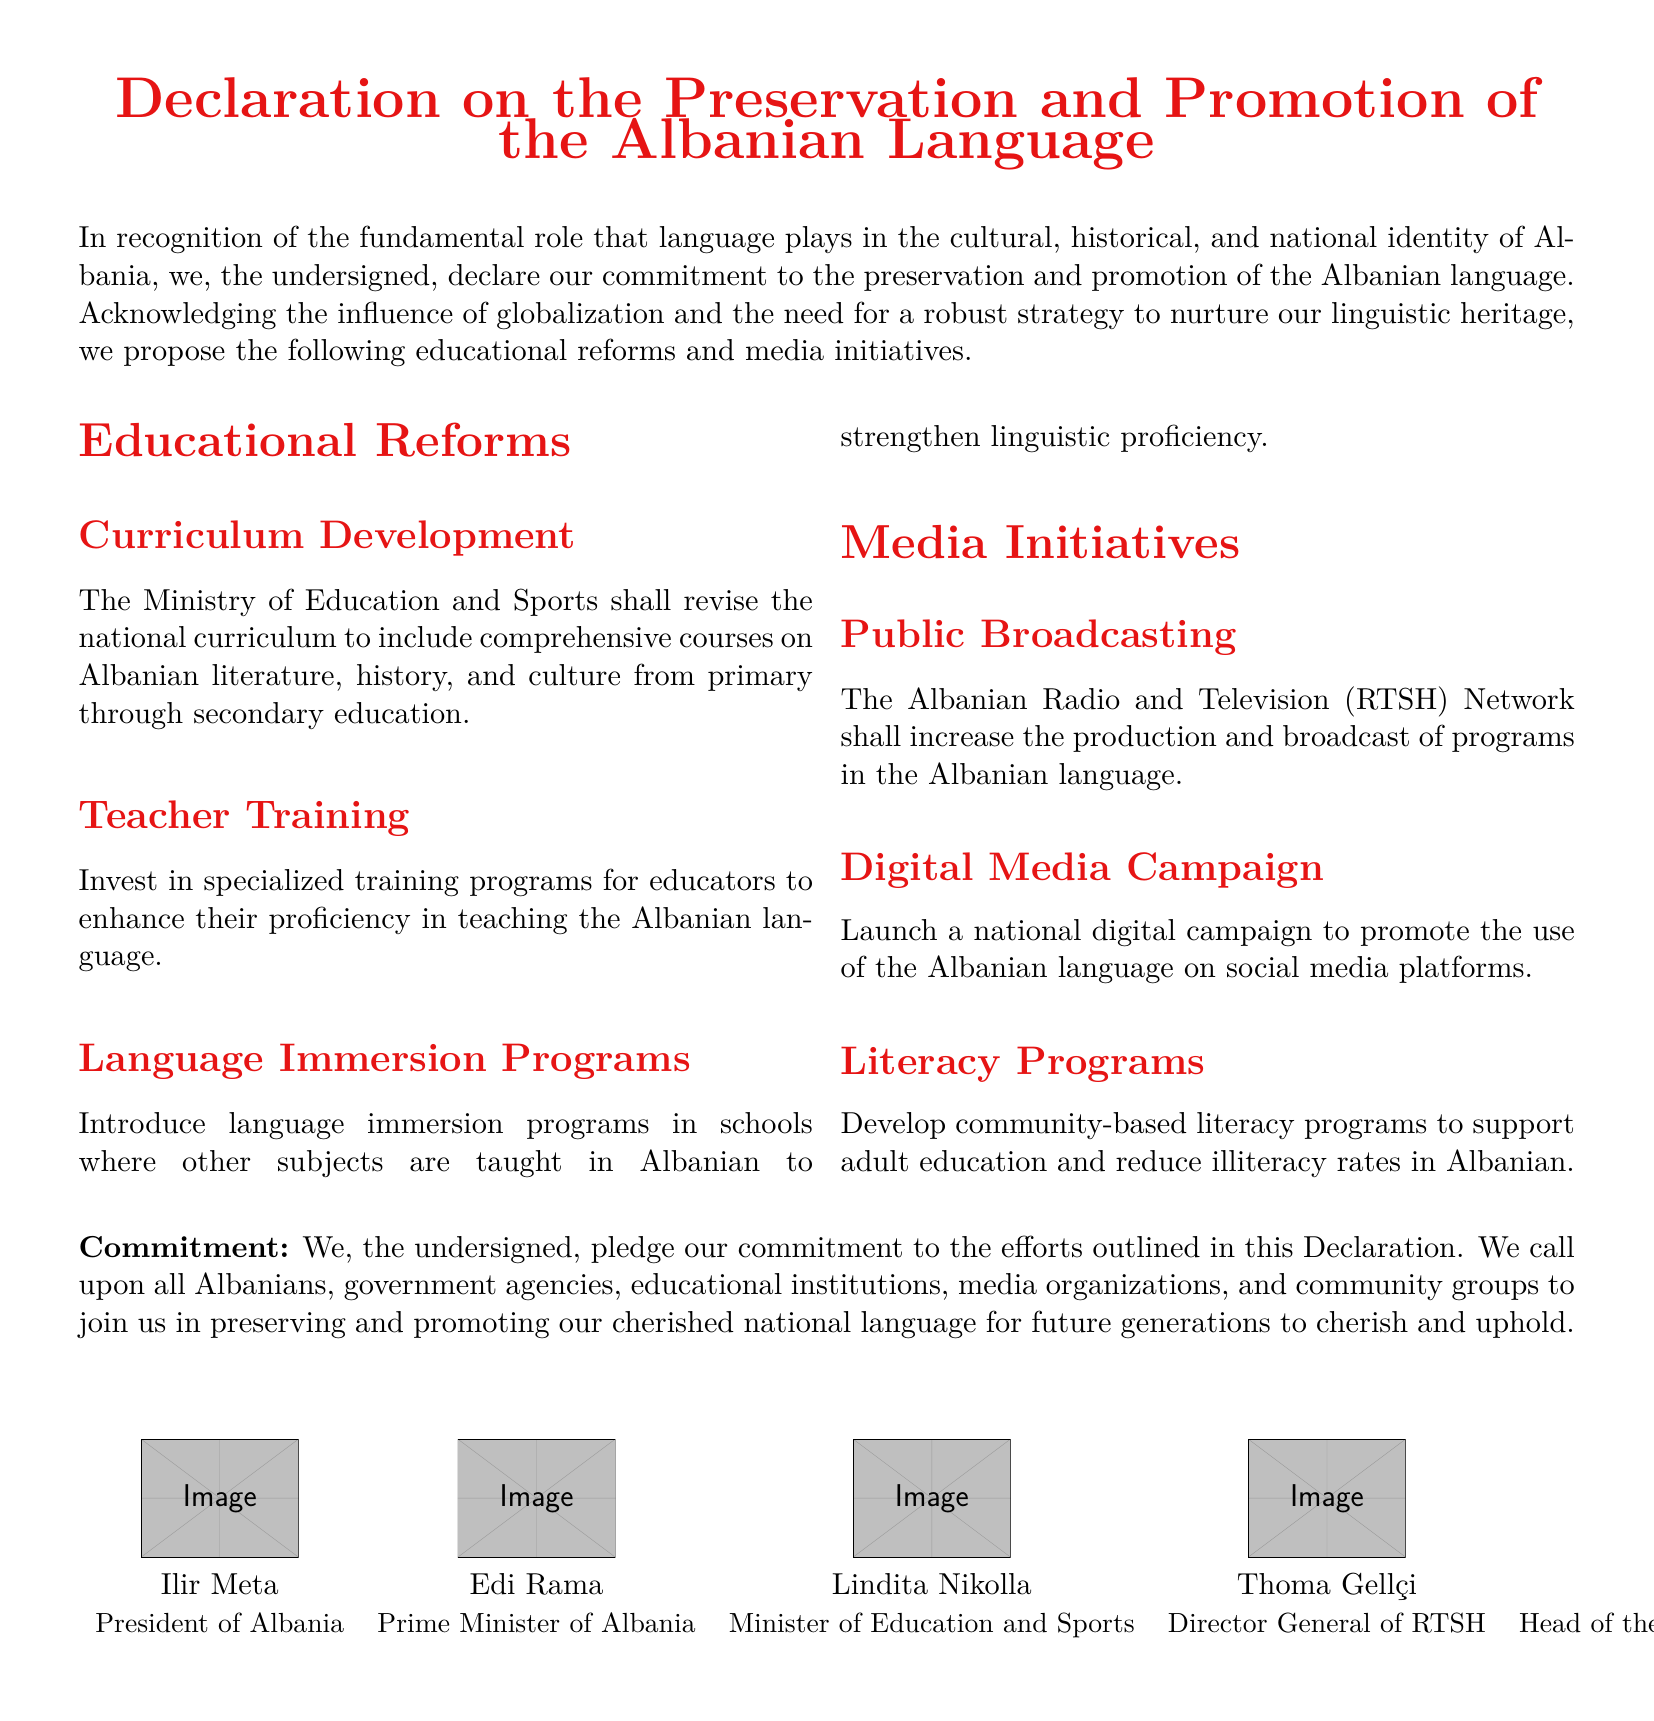What is the title of the document? The title is explicitly stated at the beginning of the document, which is about the preservation and promotion of the Albanian language.
Answer: Declaration on the Preservation and Promotion of the Albanian Language Who is the Minister of Education and Sports? The document specifies the current Minister of Education and Sports among the signatories.
Answer: Lindita Nikolla What major initiative involves the Albanian Radio and Television Network? The document outlines a specific media initiative involving the public broadcasting network to increase production in the national language.
Answer: Public Broadcasting How many signatories are listed in the document? The document explicitly lists five individuals as signatories, each with their titles.
Answer: 5 What educational reform is aimed at teacher proficiency? The document describes an initiative focused on training educators for better language teaching.
Answer: Teacher Training What type of programs are suggested to improve literacy rates? The document mentions certain community-based activities aimed at supporting adult education in the Albanian language.
Answer: Literacy Programs Which color is specifically defined for the document? The document includes a defined color that represents the national identity in its formatting.
Answer: Albania Red What is the commitment stated in the document? The declaration closes with a pledge made by the undersigned regarding the preservation of the Albanian language.
Answer: Commitment to preservation and promotion What educational reform includes courses on literature and culture? The document refers to a specific modification in education to integrate essential academic subjects related to national identity.
Answer: Curriculum Development 